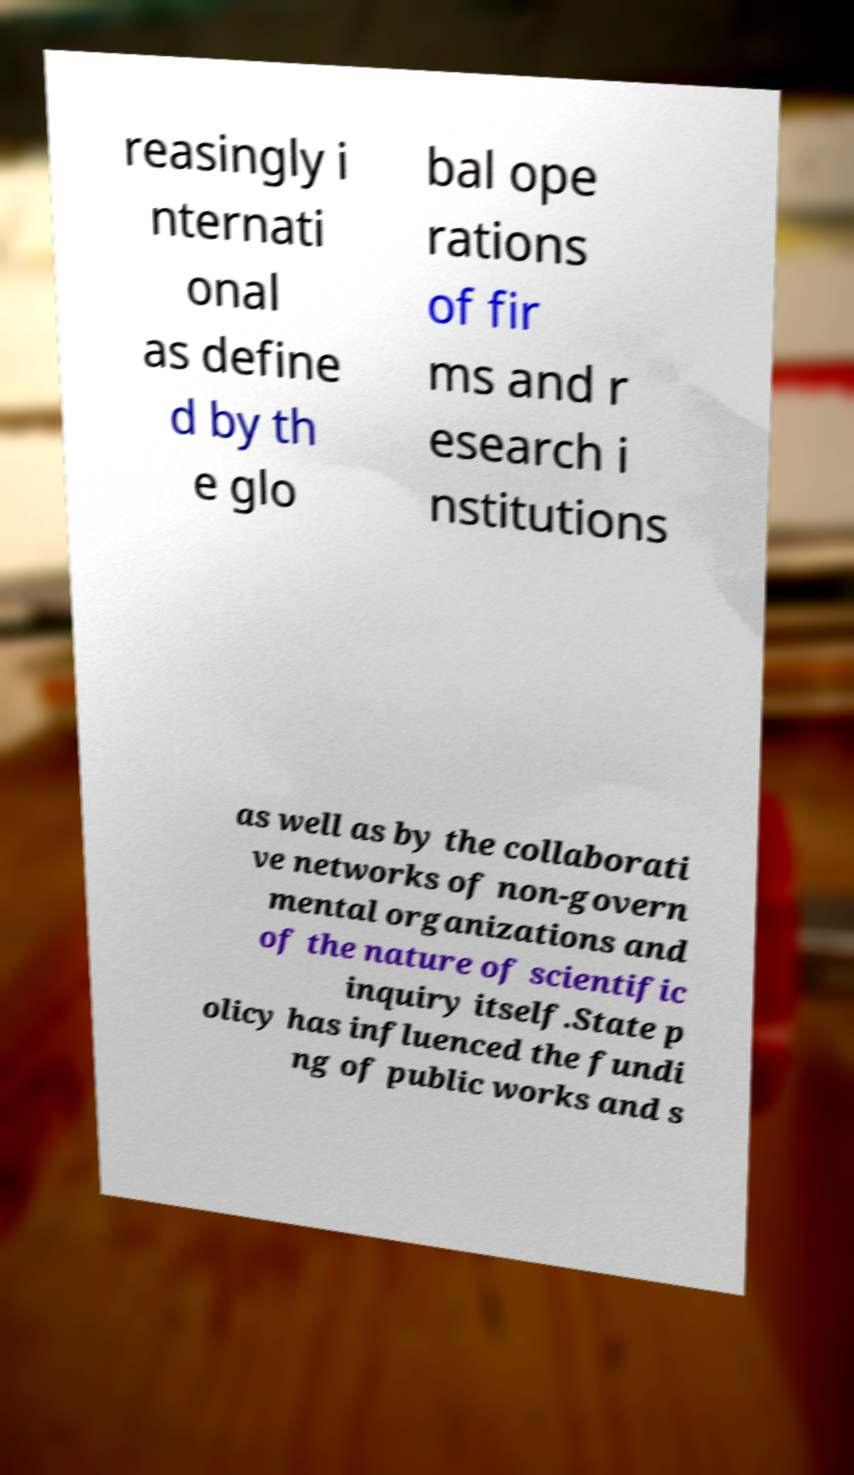What messages or text are displayed in this image? I need them in a readable, typed format. reasingly i nternati onal as define d by th e glo bal ope rations of fir ms and r esearch i nstitutions as well as by the collaborati ve networks of non-govern mental organizations and of the nature of scientific inquiry itself.State p olicy has influenced the fundi ng of public works and s 